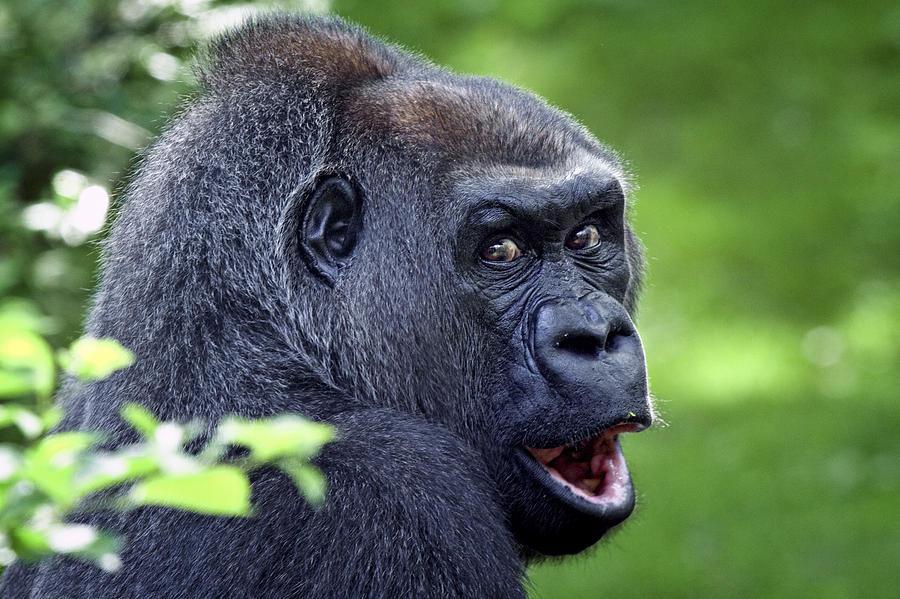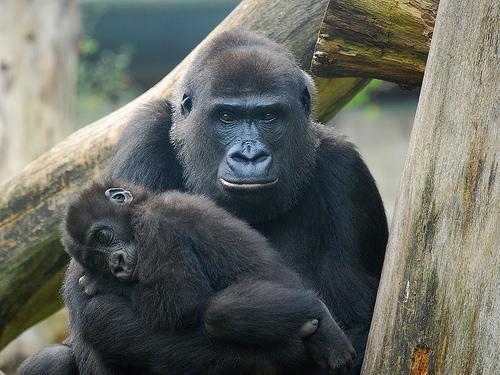The first image is the image on the left, the second image is the image on the right. Examine the images to the left and right. Is the description "At least one of the images shows an adult gorilla carrying a baby gorilla on their back, with the baby touching the adult's shoulders." accurate? Answer yes or no. No. The first image is the image on the left, the second image is the image on the right. Evaluate the accuracy of this statement regarding the images: "An image shows a baby gorilla clinging on the back near the shoulders of an adult gorilla.". Is it true? Answer yes or no. No. 